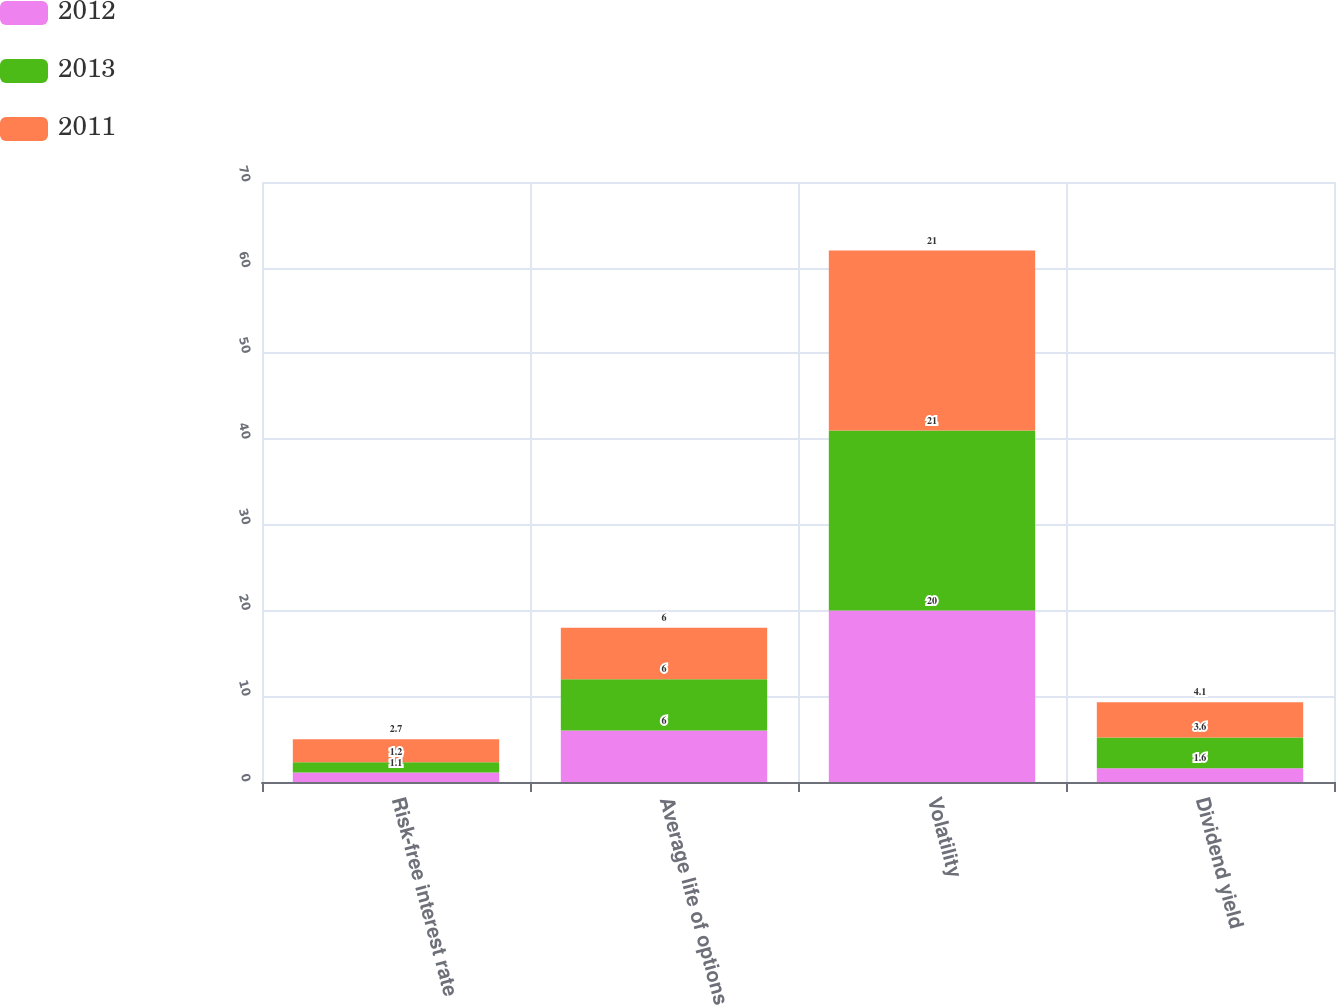<chart> <loc_0><loc_0><loc_500><loc_500><stacked_bar_chart><ecel><fcel>Risk-free interest rate<fcel>Average life of options<fcel>Volatility<fcel>Dividend yield<nl><fcel>2012<fcel>1.1<fcel>6<fcel>20<fcel>1.6<nl><fcel>2013<fcel>1.2<fcel>6<fcel>21<fcel>3.6<nl><fcel>2011<fcel>2.7<fcel>6<fcel>21<fcel>4.1<nl></chart> 